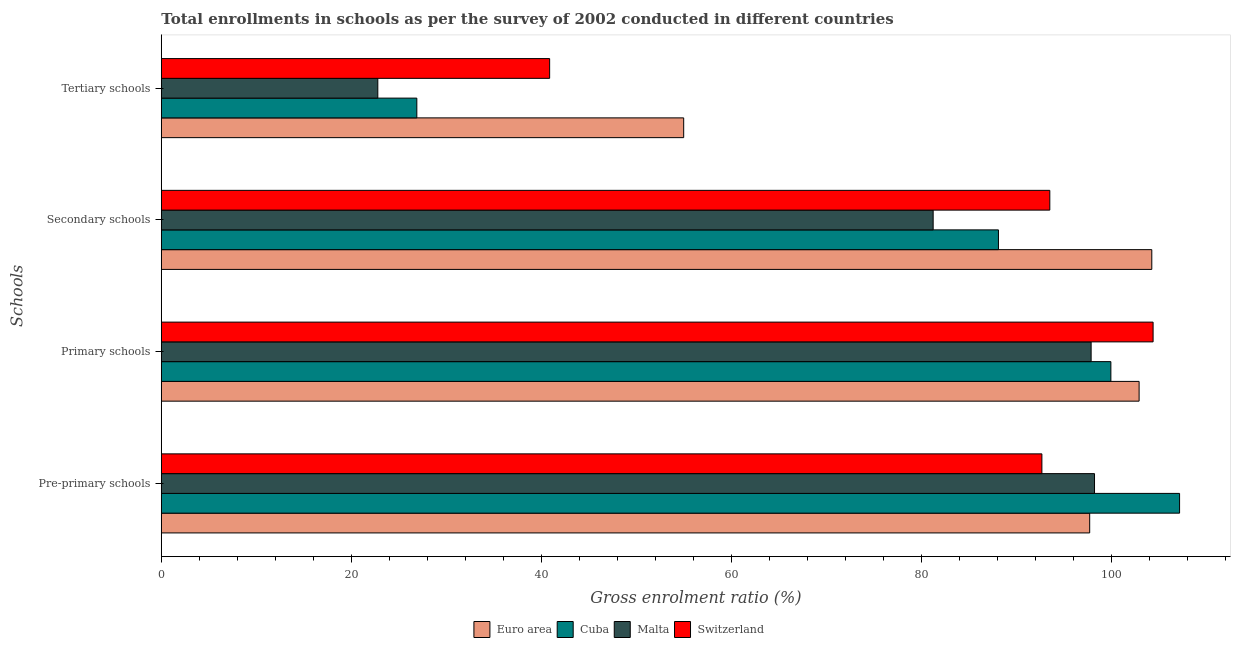Are the number of bars per tick equal to the number of legend labels?
Ensure brevity in your answer.  Yes. What is the label of the 4th group of bars from the top?
Your answer should be very brief. Pre-primary schools. What is the gross enrolment ratio in secondary schools in Malta?
Ensure brevity in your answer.  81.2. Across all countries, what is the maximum gross enrolment ratio in secondary schools?
Offer a terse response. 104.2. Across all countries, what is the minimum gross enrolment ratio in secondary schools?
Offer a terse response. 81.2. In which country was the gross enrolment ratio in tertiary schools maximum?
Provide a succinct answer. Euro area. In which country was the gross enrolment ratio in secondary schools minimum?
Provide a short and direct response. Malta. What is the total gross enrolment ratio in tertiary schools in the graph?
Ensure brevity in your answer.  145.46. What is the difference between the gross enrolment ratio in pre-primary schools in Malta and that in Switzerland?
Provide a short and direct response. 5.54. What is the difference between the gross enrolment ratio in pre-primary schools in Malta and the gross enrolment ratio in tertiary schools in Cuba?
Offer a terse response. 71.29. What is the average gross enrolment ratio in secondary schools per country?
Your response must be concise. 91.73. What is the difference between the gross enrolment ratio in primary schools and gross enrolment ratio in tertiary schools in Switzerland?
Your answer should be very brief. 63.48. In how many countries, is the gross enrolment ratio in tertiary schools greater than 48 %?
Your answer should be compact. 1. What is the ratio of the gross enrolment ratio in secondary schools in Cuba to that in Euro area?
Your response must be concise. 0.85. Is the gross enrolment ratio in primary schools in Euro area less than that in Malta?
Ensure brevity in your answer.  No. What is the difference between the highest and the second highest gross enrolment ratio in secondary schools?
Ensure brevity in your answer.  10.73. What is the difference between the highest and the lowest gross enrolment ratio in pre-primary schools?
Provide a short and direct response. 14.48. Is it the case that in every country, the sum of the gross enrolment ratio in secondary schools and gross enrolment ratio in pre-primary schools is greater than the sum of gross enrolment ratio in primary schools and gross enrolment ratio in tertiary schools?
Make the answer very short. No. What does the 3rd bar from the top in Primary schools represents?
Offer a terse response. Cuba. What does the 3rd bar from the bottom in Tertiary schools represents?
Provide a succinct answer. Malta. Are all the bars in the graph horizontal?
Provide a succinct answer. Yes. How many countries are there in the graph?
Provide a succinct answer. 4. What is the difference between two consecutive major ticks on the X-axis?
Offer a terse response. 20. Are the values on the major ticks of X-axis written in scientific E-notation?
Keep it short and to the point. No. Does the graph contain any zero values?
Your answer should be very brief. No. Where does the legend appear in the graph?
Provide a succinct answer. Bottom center. How many legend labels are there?
Offer a very short reply. 4. How are the legend labels stacked?
Offer a very short reply. Horizontal. What is the title of the graph?
Offer a very short reply. Total enrollments in schools as per the survey of 2002 conducted in different countries. What is the label or title of the X-axis?
Your response must be concise. Gross enrolment ratio (%). What is the label or title of the Y-axis?
Your response must be concise. Schools. What is the Gross enrolment ratio (%) of Euro area in Pre-primary schools?
Offer a very short reply. 97.66. What is the Gross enrolment ratio (%) in Cuba in Pre-primary schools?
Give a very brief answer. 107.12. What is the Gross enrolment ratio (%) in Malta in Pre-primary schools?
Make the answer very short. 98.17. What is the Gross enrolment ratio (%) of Switzerland in Pre-primary schools?
Ensure brevity in your answer.  92.63. What is the Gross enrolment ratio (%) of Euro area in Primary schools?
Keep it short and to the point. 102.86. What is the Gross enrolment ratio (%) of Cuba in Primary schools?
Provide a succinct answer. 99.89. What is the Gross enrolment ratio (%) of Malta in Primary schools?
Make the answer very short. 97.81. What is the Gross enrolment ratio (%) in Switzerland in Primary schools?
Offer a very short reply. 104.33. What is the Gross enrolment ratio (%) in Euro area in Secondary schools?
Make the answer very short. 104.2. What is the Gross enrolment ratio (%) in Cuba in Secondary schools?
Offer a terse response. 88.07. What is the Gross enrolment ratio (%) of Malta in Secondary schools?
Give a very brief answer. 81.2. What is the Gross enrolment ratio (%) of Switzerland in Secondary schools?
Make the answer very short. 93.47. What is the Gross enrolment ratio (%) in Euro area in Tertiary schools?
Offer a very short reply. 54.95. What is the Gross enrolment ratio (%) of Cuba in Tertiary schools?
Offer a terse response. 26.88. What is the Gross enrolment ratio (%) of Malta in Tertiary schools?
Provide a succinct answer. 22.78. What is the Gross enrolment ratio (%) in Switzerland in Tertiary schools?
Ensure brevity in your answer.  40.85. Across all Schools, what is the maximum Gross enrolment ratio (%) in Euro area?
Offer a very short reply. 104.2. Across all Schools, what is the maximum Gross enrolment ratio (%) in Cuba?
Your answer should be compact. 107.12. Across all Schools, what is the maximum Gross enrolment ratio (%) of Malta?
Your answer should be very brief. 98.17. Across all Schools, what is the maximum Gross enrolment ratio (%) of Switzerland?
Make the answer very short. 104.33. Across all Schools, what is the minimum Gross enrolment ratio (%) in Euro area?
Your answer should be compact. 54.95. Across all Schools, what is the minimum Gross enrolment ratio (%) of Cuba?
Provide a short and direct response. 26.88. Across all Schools, what is the minimum Gross enrolment ratio (%) of Malta?
Your answer should be compact. 22.78. Across all Schools, what is the minimum Gross enrolment ratio (%) in Switzerland?
Your answer should be very brief. 40.85. What is the total Gross enrolment ratio (%) of Euro area in the graph?
Provide a short and direct response. 359.67. What is the total Gross enrolment ratio (%) in Cuba in the graph?
Make the answer very short. 321.96. What is the total Gross enrolment ratio (%) of Malta in the graph?
Make the answer very short. 299.96. What is the total Gross enrolment ratio (%) in Switzerland in the graph?
Offer a very short reply. 331.29. What is the difference between the Gross enrolment ratio (%) in Euro area in Pre-primary schools and that in Primary schools?
Give a very brief answer. -5.2. What is the difference between the Gross enrolment ratio (%) of Cuba in Pre-primary schools and that in Primary schools?
Provide a succinct answer. 7.23. What is the difference between the Gross enrolment ratio (%) in Malta in Pre-primary schools and that in Primary schools?
Make the answer very short. 0.36. What is the difference between the Gross enrolment ratio (%) of Switzerland in Pre-primary schools and that in Primary schools?
Keep it short and to the point. -11.7. What is the difference between the Gross enrolment ratio (%) of Euro area in Pre-primary schools and that in Secondary schools?
Provide a succinct answer. -6.53. What is the difference between the Gross enrolment ratio (%) in Cuba in Pre-primary schools and that in Secondary schools?
Your answer should be very brief. 19.05. What is the difference between the Gross enrolment ratio (%) in Malta in Pre-primary schools and that in Secondary schools?
Offer a very short reply. 16.97. What is the difference between the Gross enrolment ratio (%) in Switzerland in Pre-primary schools and that in Secondary schools?
Offer a very short reply. -0.83. What is the difference between the Gross enrolment ratio (%) of Euro area in Pre-primary schools and that in Tertiary schools?
Offer a terse response. 42.71. What is the difference between the Gross enrolment ratio (%) in Cuba in Pre-primary schools and that in Tertiary schools?
Keep it short and to the point. 80.24. What is the difference between the Gross enrolment ratio (%) of Malta in Pre-primary schools and that in Tertiary schools?
Offer a terse response. 75.39. What is the difference between the Gross enrolment ratio (%) in Switzerland in Pre-primary schools and that in Tertiary schools?
Make the answer very short. 51.78. What is the difference between the Gross enrolment ratio (%) in Euro area in Primary schools and that in Secondary schools?
Provide a succinct answer. -1.33. What is the difference between the Gross enrolment ratio (%) of Cuba in Primary schools and that in Secondary schools?
Provide a succinct answer. 11.83. What is the difference between the Gross enrolment ratio (%) in Malta in Primary schools and that in Secondary schools?
Your answer should be very brief. 16.62. What is the difference between the Gross enrolment ratio (%) of Switzerland in Primary schools and that in Secondary schools?
Your answer should be compact. 10.87. What is the difference between the Gross enrolment ratio (%) in Euro area in Primary schools and that in Tertiary schools?
Give a very brief answer. 47.91. What is the difference between the Gross enrolment ratio (%) of Cuba in Primary schools and that in Tertiary schools?
Ensure brevity in your answer.  73.01. What is the difference between the Gross enrolment ratio (%) in Malta in Primary schools and that in Tertiary schools?
Make the answer very short. 75.04. What is the difference between the Gross enrolment ratio (%) in Switzerland in Primary schools and that in Tertiary schools?
Provide a succinct answer. 63.48. What is the difference between the Gross enrolment ratio (%) in Euro area in Secondary schools and that in Tertiary schools?
Make the answer very short. 49.24. What is the difference between the Gross enrolment ratio (%) in Cuba in Secondary schools and that in Tertiary schools?
Provide a succinct answer. 61.19. What is the difference between the Gross enrolment ratio (%) in Malta in Secondary schools and that in Tertiary schools?
Your answer should be very brief. 58.42. What is the difference between the Gross enrolment ratio (%) in Switzerland in Secondary schools and that in Tertiary schools?
Ensure brevity in your answer.  52.62. What is the difference between the Gross enrolment ratio (%) in Euro area in Pre-primary schools and the Gross enrolment ratio (%) in Cuba in Primary schools?
Provide a short and direct response. -2.23. What is the difference between the Gross enrolment ratio (%) of Euro area in Pre-primary schools and the Gross enrolment ratio (%) of Malta in Primary schools?
Your answer should be compact. -0.15. What is the difference between the Gross enrolment ratio (%) in Euro area in Pre-primary schools and the Gross enrolment ratio (%) in Switzerland in Primary schools?
Make the answer very short. -6.67. What is the difference between the Gross enrolment ratio (%) of Cuba in Pre-primary schools and the Gross enrolment ratio (%) of Malta in Primary schools?
Provide a succinct answer. 9.3. What is the difference between the Gross enrolment ratio (%) of Cuba in Pre-primary schools and the Gross enrolment ratio (%) of Switzerland in Primary schools?
Your response must be concise. 2.79. What is the difference between the Gross enrolment ratio (%) in Malta in Pre-primary schools and the Gross enrolment ratio (%) in Switzerland in Primary schools?
Keep it short and to the point. -6.16. What is the difference between the Gross enrolment ratio (%) in Euro area in Pre-primary schools and the Gross enrolment ratio (%) in Cuba in Secondary schools?
Provide a short and direct response. 9.6. What is the difference between the Gross enrolment ratio (%) in Euro area in Pre-primary schools and the Gross enrolment ratio (%) in Malta in Secondary schools?
Offer a terse response. 16.47. What is the difference between the Gross enrolment ratio (%) of Euro area in Pre-primary schools and the Gross enrolment ratio (%) of Switzerland in Secondary schools?
Your response must be concise. 4.2. What is the difference between the Gross enrolment ratio (%) of Cuba in Pre-primary schools and the Gross enrolment ratio (%) of Malta in Secondary schools?
Keep it short and to the point. 25.92. What is the difference between the Gross enrolment ratio (%) in Cuba in Pre-primary schools and the Gross enrolment ratio (%) in Switzerland in Secondary schools?
Provide a short and direct response. 13.65. What is the difference between the Gross enrolment ratio (%) in Malta in Pre-primary schools and the Gross enrolment ratio (%) in Switzerland in Secondary schools?
Offer a very short reply. 4.7. What is the difference between the Gross enrolment ratio (%) in Euro area in Pre-primary schools and the Gross enrolment ratio (%) in Cuba in Tertiary schools?
Keep it short and to the point. 70.78. What is the difference between the Gross enrolment ratio (%) in Euro area in Pre-primary schools and the Gross enrolment ratio (%) in Malta in Tertiary schools?
Offer a very short reply. 74.89. What is the difference between the Gross enrolment ratio (%) of Euro area in Pre-primary schools and the Gross enrolment ratio (%) of Switzerland in Tertiary schools?
Keep it short and to the point. 56.81. What is the difference between the Gross enrolment ratio (%) of Cuba in Pre-primary schools and the Gross enrolment ratio (%) of Malta in Tertiary schools?
Offer a terse response. 84.34. What is the difference between the Gross enrolment ratio (%) of Cuba in Pre-primary schools and the Gross enrolment ratio (%) of Switzerland in Tertiary schools?
Give a very brief answer. 66.27. What is the difference between the Gross enrolment ratio (%) of Malta in Pre-primary schools and the Gross enrolment ratio (%) of Switzerland in Tertiary schools?
Your response must be concise. 57.32. What is the difference between the Gross enrolment ratio (%) in Euro area in Primary schools and the Gross enrolment ratio (%) in Cuba in Secondary schools?
Keep it short and to the point. 14.8. What is the difference between the Gross enrolment ratio (%) in Euro area in Primary schools and the Gross enrolment ratio (%) in Malta in Secondary schools?
Ensure brevity in your answer.  21.67. What is the difference between the Gross enrolment ratio (%) in Euro area in Primary schools and the Gross enrolment ratio (%) in Switzerland in Secondary schools?
Provide a succinct answer. 9.39. What is the difference between the Gross enrolment ratio (%) of Cuba in Primary schools and the Gross enrolment ratio (%) of Malta in Secondary schools?
Ensure brevity in your answer.  18.7. What is the difference between the Gross enrolment ratio (%) in Cuba in Primary schools and the Gross enrolment ratio (%) in Switzerland in Secondary schools?
Make the answer very short. 6.42. What is the difference between the Gross enrolment ratio (%) in Malta in Primary schools and the Gross enrolment ratio (%) in Switzerland in Secondary schools?
Make the answer very short. 4.35. What is the difference between the Gross enrolment ratio (%) of Euro area in Primary schools and the Gross enrolment ratio (%) of Cuba in Tertiary schools?
Keep it short and to the point. 75.98. What is the difference between the Gross enrolment ratio (%) of Euro area in Primary schools and the Gross enrolment ratio (%) of Malta in Tertiary schools?
Your answer should be compact. 80.09. What is the difference between the Gross enrolment ratio (%) of Euro area in Primary schools and the Gross enrolment ratio (%) of Switzerland in Tertiary schools?
Your answer should be compact. 62.01. What is the difference between the Gross enrolment ratio (%) of Cuba in Primary schools and the Gross enrolment ratio (%) of Malta in Tertiary schools?
Your answer should be very brief. 77.12. What is the difference between the Gross enrolment ratio (%) of Cuba in Primary schools and the Gross enrolment ratio (%) of Switzerland in Tertiary schools?
Provide a succinct answer. 59.04. What is the difference between the Gross enrolment ratio (%) in Malta in Primary schools and the Gross enrolment ratio (%) in Switzerland in Tertiary schools?
Ensure brevity in your answer.  56.96. What is the difference between the Gross enrolment ratio (%) in Euro area in Secondary schools and the Gross enrolment ratio (%) in Cuba in Tertiary schools?
Your answer should be compact. 77.32. What is the difference between the Gross enrolment ratio (%) in Euro area in Secondary schools and the Gross enrolment ratio (%) in Malta in Tertiary schools?
Keep it short and to the point. 81.42. What is the difference between the Gross enrolment ratio (%) of Euro area in Secondary schools and the Gross enrolment ratio (%) of Switzerland in Tertiary schools?
Provide a short and direct response. 63.35. What is the difference between the Gross enrolment ratio (%) of Cuba in Secondary schools and the Gross enrolment ratio (%) of Malta in Tertiary schools?
Make the answer very short. 65.29. What is the difference between the Gross enrolment ratio (%) in Cuba in Secondary schools and the Gross enrolment ratio (%) in Switzerland in Tertiary schools?
Give a very brief answer. 47.21. What is the difference between the Gross enrolment ratio (%) in Malta in Secondary schools and the Gross enrolment ratio (%) in Switzerland in Tertiary schools?
Your answer should be compact. 40.34. What is the average Gross enrolment ratio (%) in Euro area per Schools?
Provide a short and direct response. 89.92. What is the average Gross enrolment ratio (%) in Cuba per Schools?
Your answer should be very brief. 80.49. What is the average Gross enrolment ratio (%) of Malta per Schools?
Provide a short and direct response. 74.99. What is the average Gross enrolment ratio (%) in Switzerland per Schools?
Keep it short and to the point. 82.82. What is the difference between the Gross enrolment ratio (%) of Euro area and Gross enrolment ratio (%) of Cuba in Pre-primary schools?
Keep it short and to the point. -9.46. What is the difference between the Gross enrolment ratio (%) of Euro area and Gross enrolment ratio (%) of Malta in Pre-primary schools?
Provide a short and direct response. -0.51. What is the difference between the Gross enrolment ratio (%) in Euro area and Gross enrolment ratio (%) in Switzerland in Pre-primary schools?
Give a very brief answer. 5.03. What is the difference between the Gross enrolment ratio (%) of Cuba and Gross enrolment ratio (%) of Malta in Pre-primary schools?
Offer a very short reply. 8.95. What is the difference between the Gross enrolment ratio (%) in Cuba and Gross enrolment ratio (%) in Switzerland in Pre-primary schools?
Keep it short and to the point. 14.48. What is the difference between the Gross enrolment ratio (%) of Malta and Gross enrolment ratio (%) of Switzerland in Pre-primary schools?
Ensure brevity in your answer.  5.54. What is the difference between the Gross enrolment ratio (%) of Euro area and Gross enrolment ratio (%) of Cuba in Primary schools?
Your response must be concise. 2.97. What is the difference between the Gross enrolment ratio (%) of Euro area and Gross enrolment ratio (%) of Malta in Primary schools?
Keep it short and to the point. 5.05. What is the difference between the Gross enrolment ratio (%) of Euro area and Gross enrolment ratio (%) of Switzerland in Primary schools?
Offer a very short reply. -1.47. What is the difference between the Gross enrolment ratio (%) of Cuba and Gross enrolment ratio (%) of Malta in Primary schools?
Ensure brevity in your answer.  2.08. What is the difference between the Gross enrolment ratio (%) of Cuba and Gross enrolment ratio (%) of Switzerland in Primary schools?
Your answer should be very brief. -4.44. What is the difference between the Gross enrolment ratio (%) of Malta and Gross enrolment ratio (%) of Switzerland in Primary schools?
Offer a very short reply. -6.52. What is the difference between the Gross enrolment ratio (%) of Euro area and Gross enrolment ratio (%) of Cuba in Secondary schools?
Ensure brevity in your answer.  16.13. What is the difference between the Gross enrolment ratio (%) in Euro area and Gross enrolment ratio (%) in Malta in Secondary schools?
Offer a very short reply. 23. What is the difference between the Gross enrolment ratio (%) of Euro area and Gross enrolment ratio (%) of Switzerland in Secondary schools?
Keep it short and to the point. 10.73. What is the difference between the Gross enrolment ratio (%) in Cuba and Gross enrolment ratio (%) in Malta in Secondary schools?
Offer a terse response. 6.87. What is the difference between the Gross enrolment ratio (%) in Cuba and Gross enrolment ratio (%) in Switzerland in Secondary schools?
Give a very brief answer. -5.4. What is the difference between the Gross enrolment ratio (%) of Malta and Gross enrolment ratio (%) of Switzerland in Secondary schools?
Your answer should be compact. -12.27. What is the difference between the Gross enrolment ratio (%) in Euro area and Gross enrolment ratio (%) in Cuba in Tertiary schools?
Offer a terse response. 28.07. What is the difference between the Gross enrolment ratio (%) of Euro area and Gross enrolment ratio (%) of Malta in Tertiary schools?
Offer a very short reply. 32.18. What is the difference between the Gross enrolment ratio (%) in Euro area and Gross enrolment ratio (%) in Switzerland in Tertiary schools?
Offer a terse response. 14.1. What is the difference between the Gross enrolment ratio (%) in Cuba and Gross enrolment ratio (%) in Malta in Tertiary schools?
Your response must be concise. 4.1. What is the difference between the Gross enrolment ratio (%) in Cuba and Gross enrolment ratio (%) in Switzerland in Tertiary schools?
Provide a short and direct response. -13.97. What is the difference between the Gross enrolment ratio (%) of Malta and Gross enrolment ratio (%) of Switzerland in Tertiary schools?
Make the answer very short. -18.08. What is the ratio of the Gross enrolment ratio (%) of Euro area in Pre-primary schools to that in Primary schools?
Provide a succinct answer. 0.95. What is the ratio of the Gross enrolment ratio (%) in Cuba in Pre-primary schools to that in Primary schools?
Make the answer very short. 1.07. What is the ratio of the Gross enrolment ratio (%) in Malta in Pre-primary schools to that in Primary schools?
Offer a very short reply. 1. What is the ratio of the Gross enrolment ratio (%) in Switzerland in Pre-primary schools to that in Primary schools?
Your response must be concise. 0.89. What is the ratio of the Gross enrolment ratio (%) in Euro area in Pre-primary schools to that in Secondary schools?
Provide a succinct answer. 0.94. What is the ratio of the Gross enrolment ratio (%) of Cuba in Pre-primary schools to that in Secondary schools?
Ensure brevity in your answer.  1.22. What is the ratio of the Gross enrolment ratio (%) of Malta in Pre-primary schools to that in Secondary schools?
Offer a terse response. 1.21. What is the ratio of the Gross enrolment ratio (%) of Switzerland in Pre-primary schools to that in Secondary schools?
Your response must be concise. 0.99. What is the ratio of the Gross enrolment ratio (%) of Euro area in Pre-primary schools to that in Tertiary schools?
Your answer should be compact. 1.78. What is the ratio of the Gross enrolment ratio (%) in Cuba in Pre-primary schools to that in Tertiary schools?
Make the answer very short. 3.99. What is the ratio of the Gross enrolment ratio (%) of Malta in Pre-primary schools to that in Tertiary schools?
Keep it short and to the point. 4.31. What is the ratio of the Gross enrolment ratio (%) in Switzerland in Pre-primary schools to that in Tertiary schools?
Keep it short and to the point. 2.27. What is the ratio of the Gross enrolment ratio (%) of Euro area in Primary schools to that in Secondary schools?
Keep it short and to the point. 0.99. What is the ratio of the Gross enrolment ratio (%) of Cuba in Primary schools to that in Secondary schools?
Provide a short and direct response. 1.13. What is the ratio of the Gross enrolment ratio (%) of Malta in Primary schools to that in Secondary schools?
Ensure brevity in your answer.  1.2. What is the ratio of the Gross enrolment ratio (%) in Switzerland in Primary schools to that in Secondary schools?
Provide a short and direct response. 1.12. What is the ratio of the Gross enrolment ratio (%) in Euro area in Primary schools to that in Tertiary schools?
Keep it short and to the point. 1.87. What is the ratio of the Gross enrolment ratio (%) in Cuba in Primary schools to that in Tertiary schools?
Offer a very short reply. 3.72. What is the ratio of the Gross enrolment ratio (%) in Malta in Primary schools to that in Tertiary schools?
Make the answer very short. 4.29. What is the ratio of the Gross enrolment ratio (%) of Switzerland in Primary schools to that in Tertiary schools?
Offer a terse response. 2.55. What is the ratio of the Gross enrolment ratio (%) of Euro area in Secondary schools to that in Tertiary schools?
Offer a terse response. 1.9. What is the ratio of the Gross enrolment ratio (%) of Cuba in Secondary schools to that in Tertiary schools?
Give a very brief answer. 3.28. What is the ratio of the Gross enrolment ratio (%) of Malta in Secondary schools to that in Tertiary schools?
Your answer should be very brief. 3.56. What is the ratio of the Gross enrolment ratio (%) of Switzerland in Secondary schools to that in Tertiary schools?
Make the answer very short. 2.29. What is the difference between the highest and the second highest Gross enrolment ratio (%) of Euro area?
Offer a terse response. 1.33. What is the difference between the highest and the second highest Gross enrolment ratio (%) of Cuba?
Make the answer very short. 7.23. What is the difference between the highest and the second highest Gross enrolment ratio (%) in Malta?
Your response must be concise. 0.36. What is the difference between the highest and the second highest Gross enrolment ratio (%) of Switzerland?
Provide a succinct answer. 10.87. What is the difference between the highest and the lowest Gross enrolment ratio (%) of Euro area?
Offer a terse response. 49.24. What is the difference between the highest and the lowest Gross enrolment ratio (%) in Cuba?
Your response must be concise. 80.24. What is the difference between the highest and the lowest Gross enrolment ratio (%) of Malta?
Your answer should be very brief. 75.39. What is the difference between the highest and the lowest Gross enrolment ratio (%) in Switzerland?
Keep it short and to the point. 63.48. 